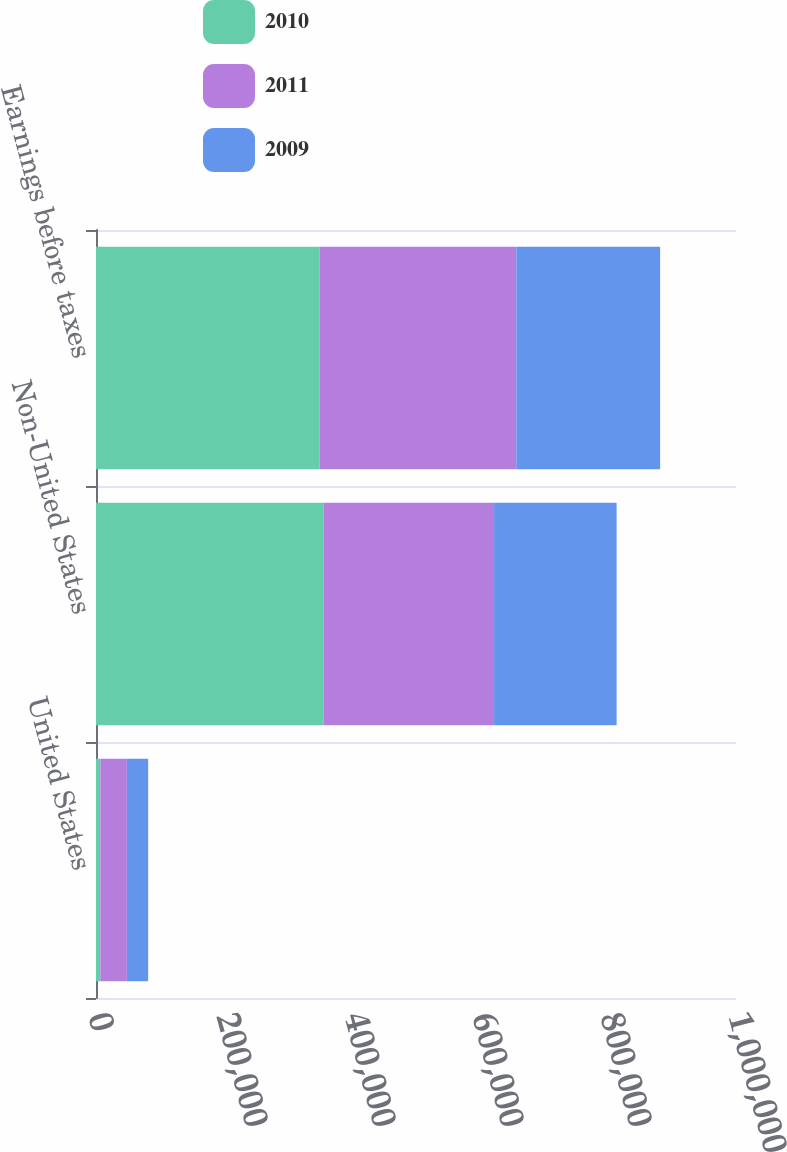Convert chart. <chart><loc_0><loc_0><loc_500><loc_500><stacked_bar_chart><ecel><fcel>United States<fcel>Non-United States<fcel>Earnings before taxes<nl><fcel>2010<fcel>6758<fcel>355935<fcel>349177<nl><fcel>2011<fcel>41470<fcel>266043<fcel>307513<nl><fcel>2009<fcel>33263<fcel>191499<fcel>224762<nl></chart> 